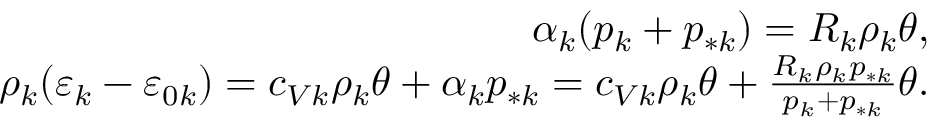<formula> <loc_0><loc_0><loc_500><loc_500>\begin{array} { r } { \alpha _ { k } ( p _ { k } + p _ { * k } ) = R _ { k } \rho _ { k } \theta , } \\ { \rho _ { k } ( \varepsilon _ { k } - \varepsilon _ { 0 k } ) = c _ { V k } \rho _ { k } \theta + \alpha _ { k } p _ { * k } = c _ { V k } \rho _ { k } \theta + \frac { R _ { k } \rho _ { k } p _ { * k } } { p _ { k } + p _ { * k } } \theta . } \end{array}</formula> 